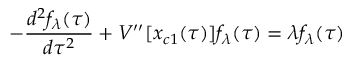<formula> <loc_0><loc_0><loc_500><loc_500>- { \frac { d ^ { 2 } f _ { \lambda } ( \tau ) } { d \tau ^ { 2 } } } + V ^ { \prime \prime } [ x _ { c 1 } ( \tau ) ] f _ { \lambda } ( \tau ) = \lambda f _ { \lambda } ( \tau )</formula> 